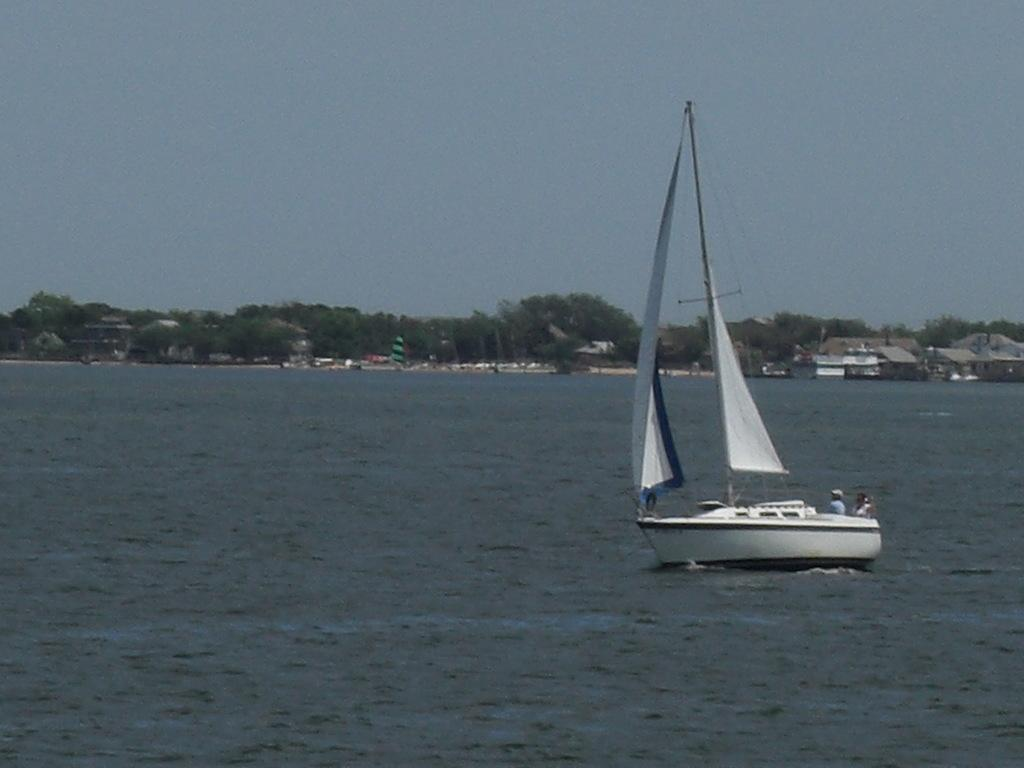What is the person in the image doing? The person is sitting in a boat. Where is the boat located? The boat is placed in the water. What can be seen in the background of the image? There are group of buildings and trees visible in the background. What else is visible in the background of the image? The sky is also visible in the background. What is the person arguing about with the trees in the background? There is no argument present in the image, and the person is not interacting with the trees. 